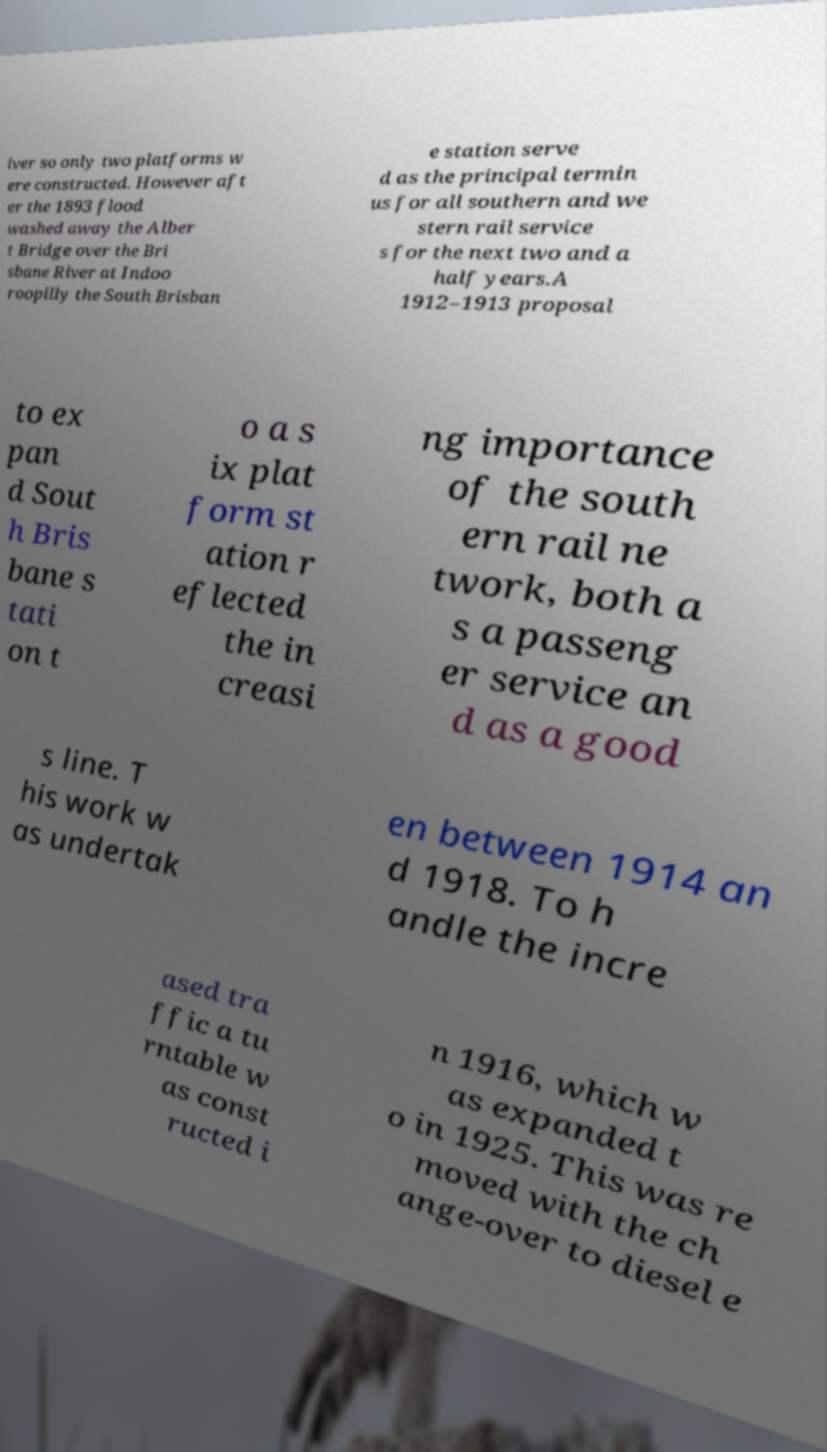There's text embedded in this image that I need extracted. Can you transcribe it verbatim? iver so only two platforms w ere constructed. However aft er the 1893 flood washed away the Alber t Bridge over the Bri sbane River at Indoo roopilly the South Brisban e station serve d as the principal termin us for all southern and we stern rail service s for the next two and a half years.A 1912–1913 proposal to ex pan d Sout h Bris bane s tati on t o a s ix plat form st ation r eflected the in creasi ng importance of the south ern rail ne twork, both a s a passeng er service an d as a good s line. T his work w as undertak en between 1914 an d 1918. To h andle the incre ased tra ffic a tu rntable w as const ructed i n 1916, which w as expanded t o in 1925. This was re moved with the ch ange-over to diesel e 